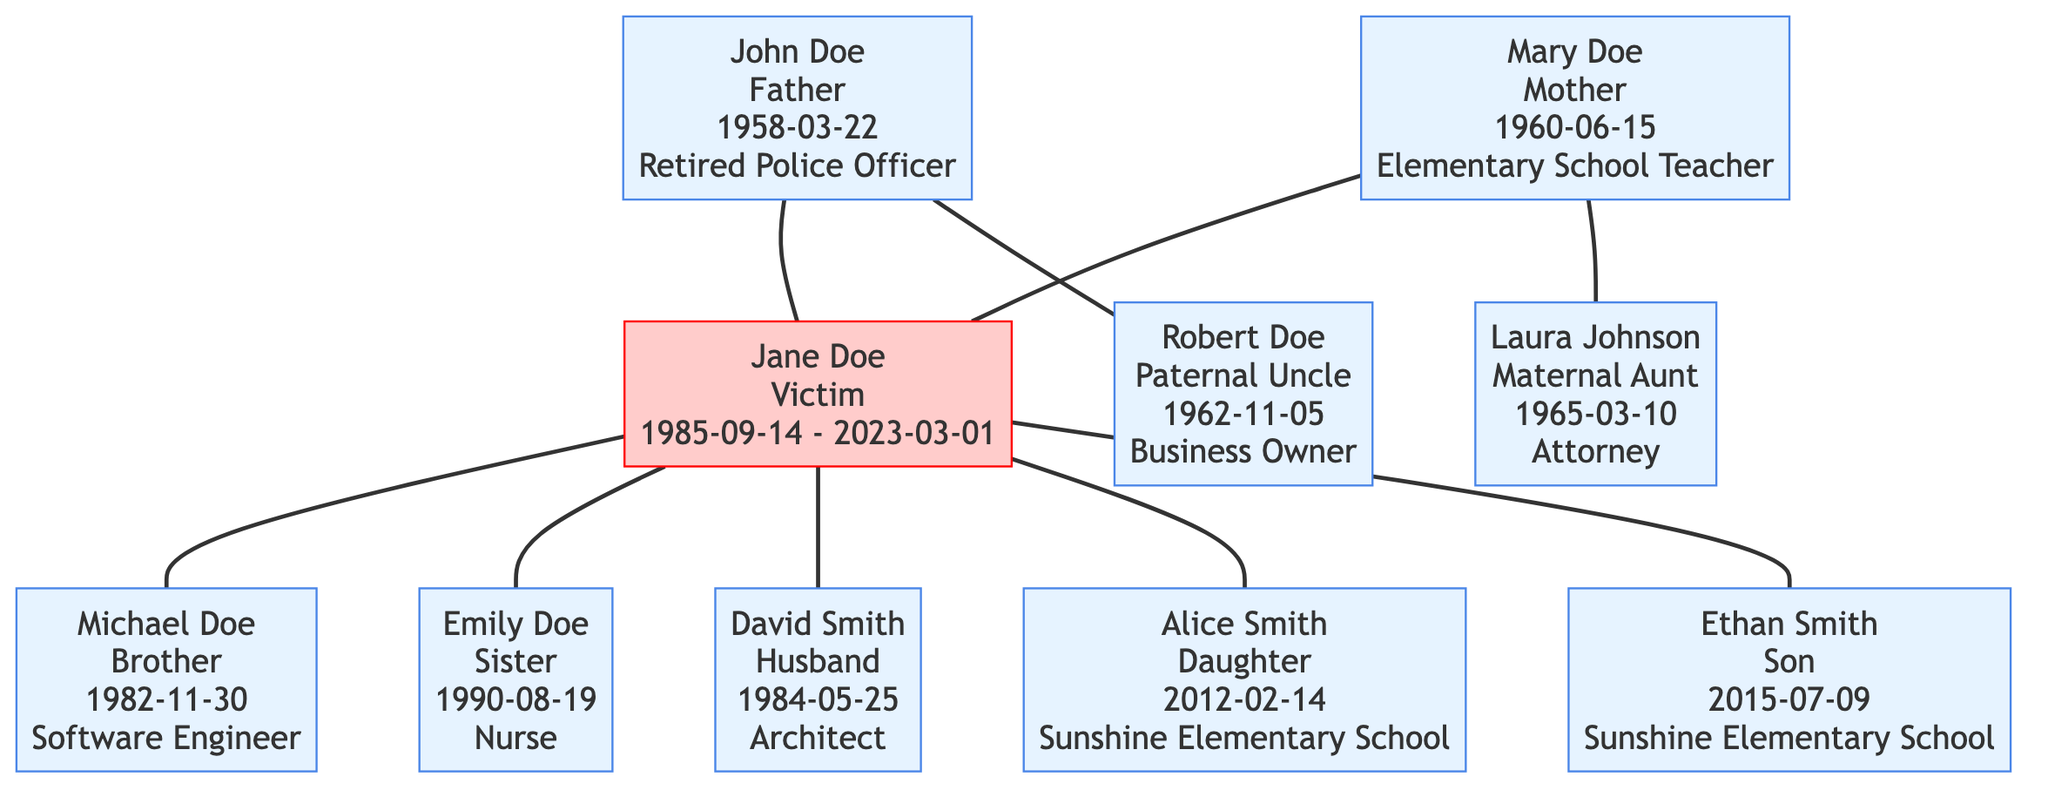What is the occupation of Jane Doe's father? According to the diagram, Jane Doe's father, John Doe, is listed with the occupation "Retired Police Officer."
Answer: Retired Police Officer How many siblings does Jane Doe have? By examining the diagram, we see that Jane Doe has two siblings: one brother and one sister.
Answer: 2 Who is the maternal aunt of Jane Doe? The diagram shows that Jane Doe's maternal aunt is Laura Johnson, who is connected to Mary Doe, Jane's mother.
Answer: Laura Johnson What is the birth date of Ethan Smith? Looking at the diagram, Ethan Smith's birth date is displayed as "2015-07-09."
Answer: 2015-07-09 Which family member has the occupation of Attorney? The diagram indicates that Laura Johnson, who is Jane Doe's maternal aunt, works as an Attorney.
Answer: Attorney Who are Jane Doe's children? By reviewing the diagram, we identify Jane Doe's children: Alice Smith and Ethan Smith, both connected to her as their mother.
Answer: Alice Smith, Ethan Smith What is the common school attended by Jane Doe's children? In the diagram, both Alice Smith and Ethan Smith are noted as attending "Sunshine Elementary School."
Answer: Sunshine Elementary School What is the relationship of David Smith to Jane Doe? The diagram defines David Smith as Jane Doe's husband, illustrating his connection to her in the family tree.
Answer: Husband What year was Jane Doe born? The diagram lists Jane Doe's birth date as "1985-09-14," indicating her birth year is 1985.
Answer: 1985 